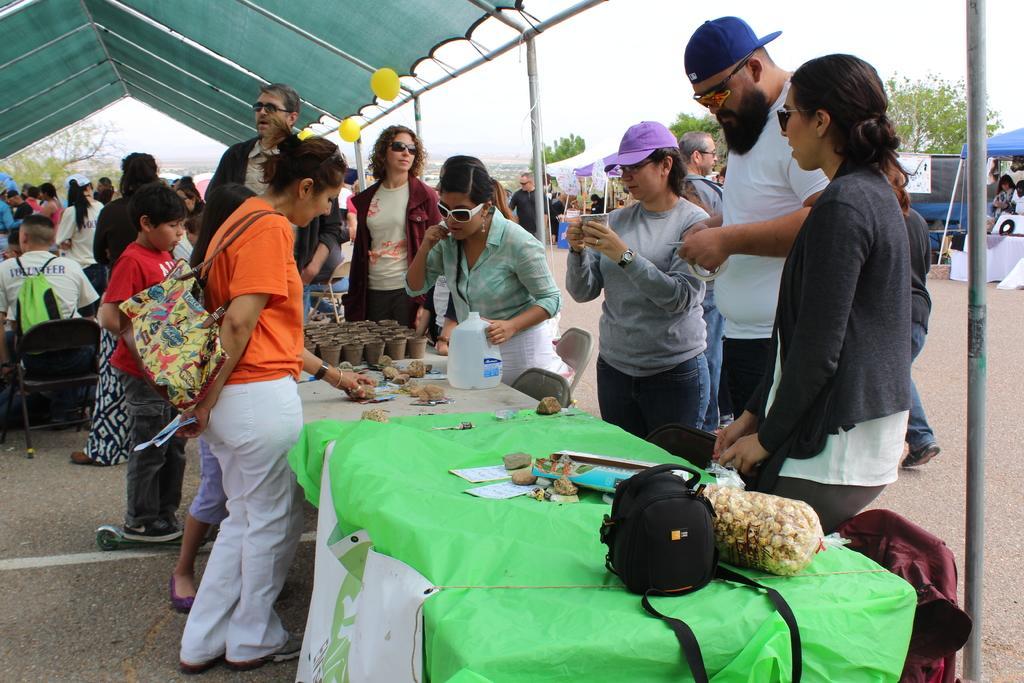Please provide a concise description of this image. In this image I can see a tent , under the tent I can see crowd of people , in the foreground I can see a table , on the table I can see bag, cover, glasses, bottle ,green color cloth , in front of table I can see group of people, in the middle there is a road, and the sky and tree some tents and persons visible. 